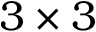<formula> <loc_0><loc_0><loc_500><loc_500>3 \times 3</formula> 